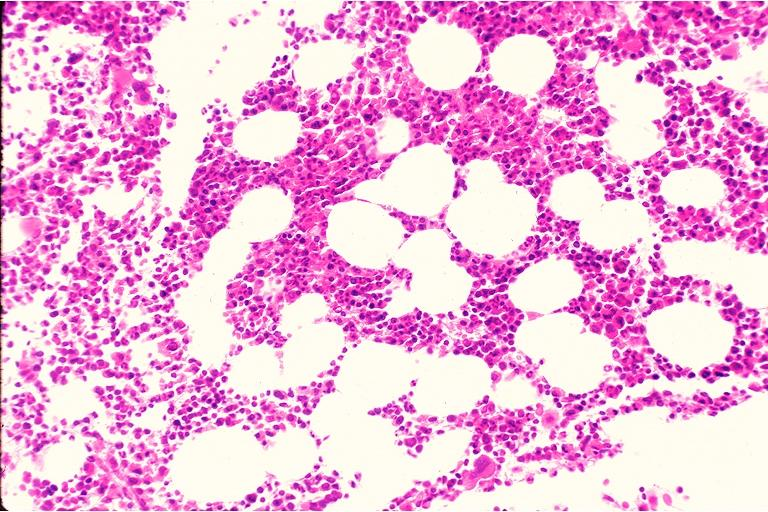what does this image show?
Answer the question using a single word or phrase. Hematopoietic bone marrow defect 